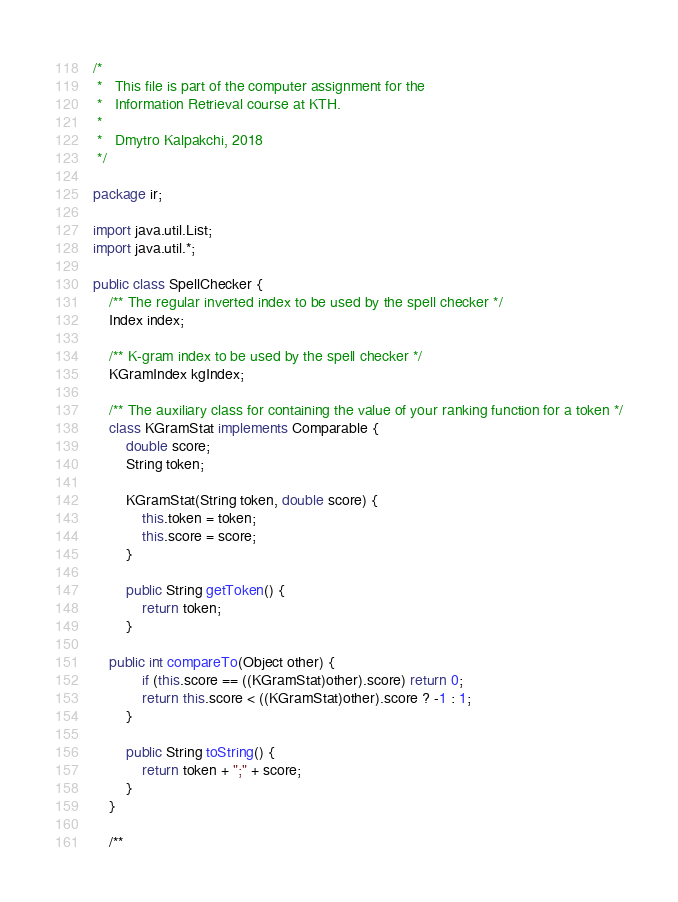<code> <loc_0><loc_0><loc_500><loc_500><_Java_>/*
 *   This file is part of the computer assignment for the
 *   Information Retrieval course at KTH.
 *
 *   Dmytro Kalpakchi, 2018
 */

package ir;

import java.util.List;
import java.util.*;

public class SpellChecker {
    /** The regular inverted index to be used by the spell checker */
    Index index;

    /** K-gram index to be used by the spell checker */
    KGramIndex kgIndex;

    /** The auxiliary class for containing the value of your ranking function for a token */
    class KGramStat implements Comparable {
        double score;
        String token;

        KGramStat(String token, double score) {
            this.token = token;
            this.score = score;
        }

        public String getToken() {
            return token;
        }

	public int compareTo(Object other) {
            if (this.score == ((KGramStat)other).score) return 0;
            return this.score < ((KGramStat)other).score ? -1 : 1;
        }

        public String toString() {
            return token + ";" + score;
        }
    }

    /**</code> 